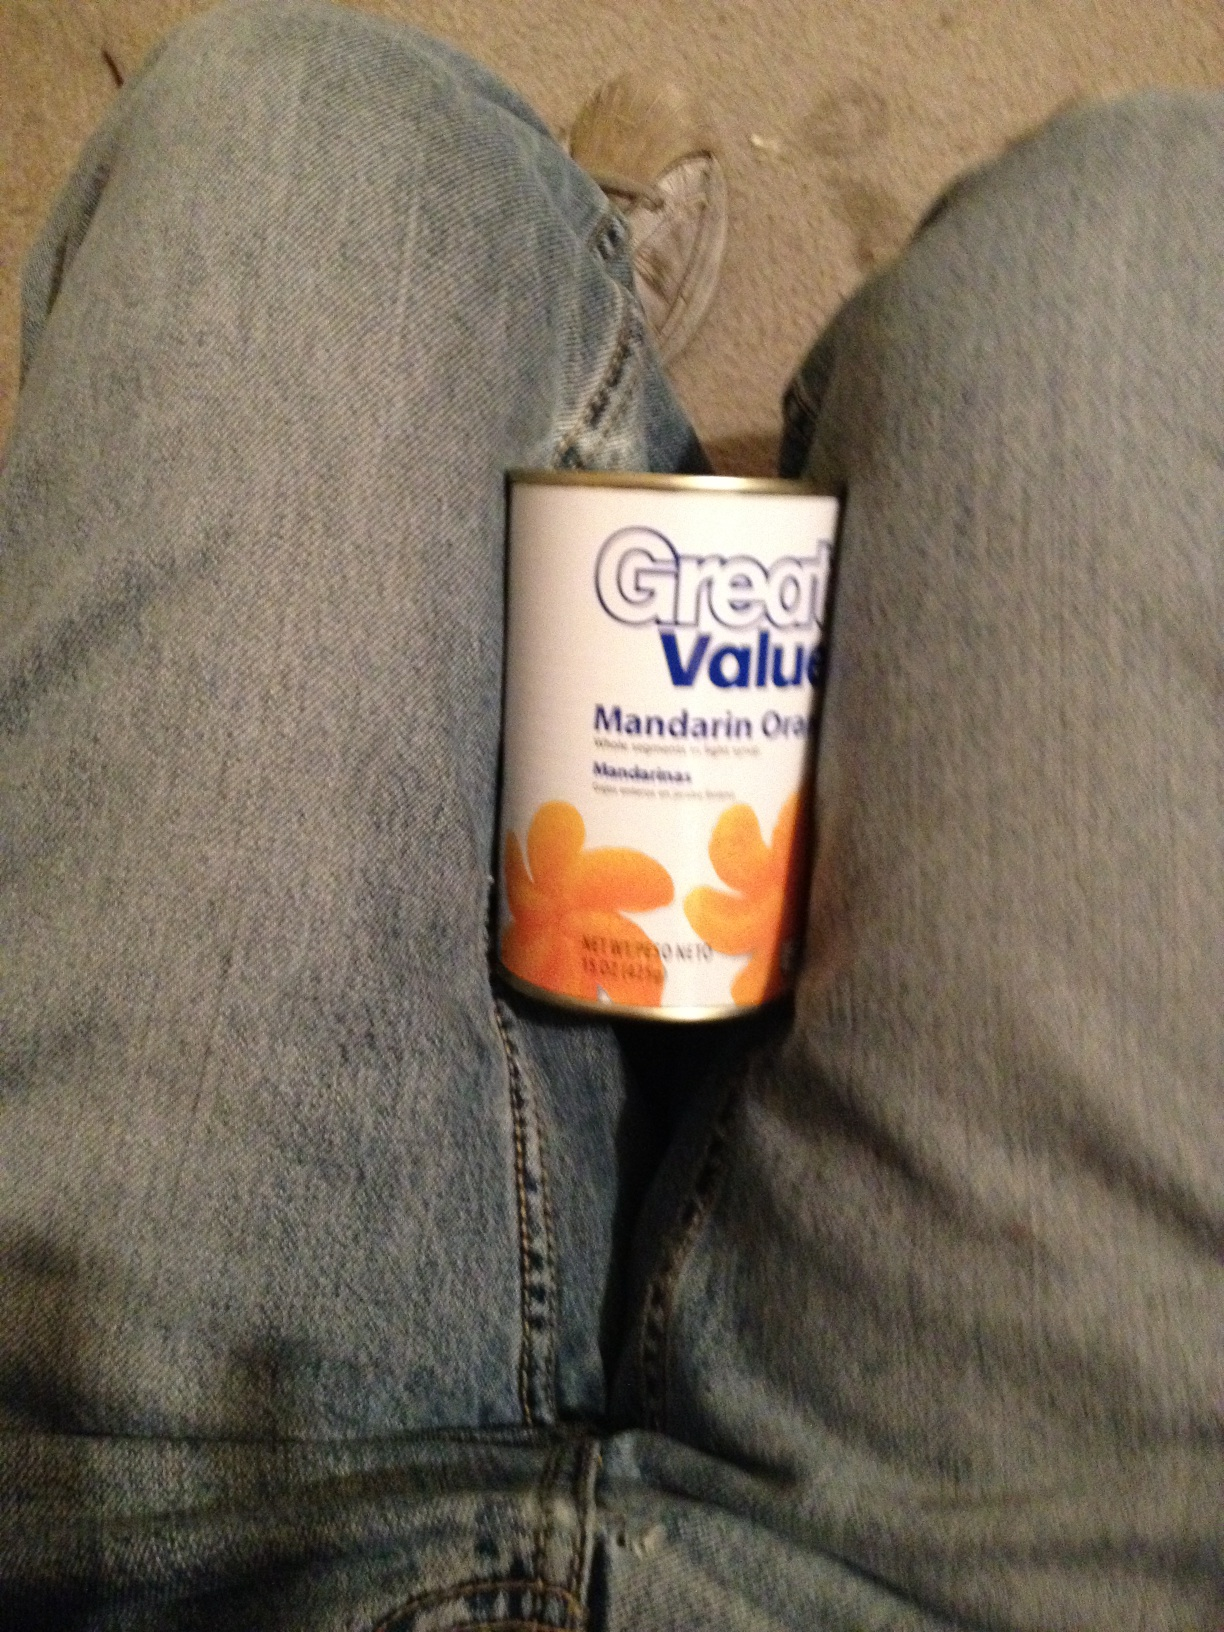What kind of soup is this? The image does not show a type of soup. Instead, it shows a can of mandarin oranges. 